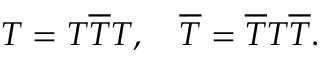Convert formula to latex. <formula><loc_0><loc_0><loc_500><loc_500>T = T \overline { T } T , \quad \overline { T } = \overline { T } T \overline { T } .</formula> 